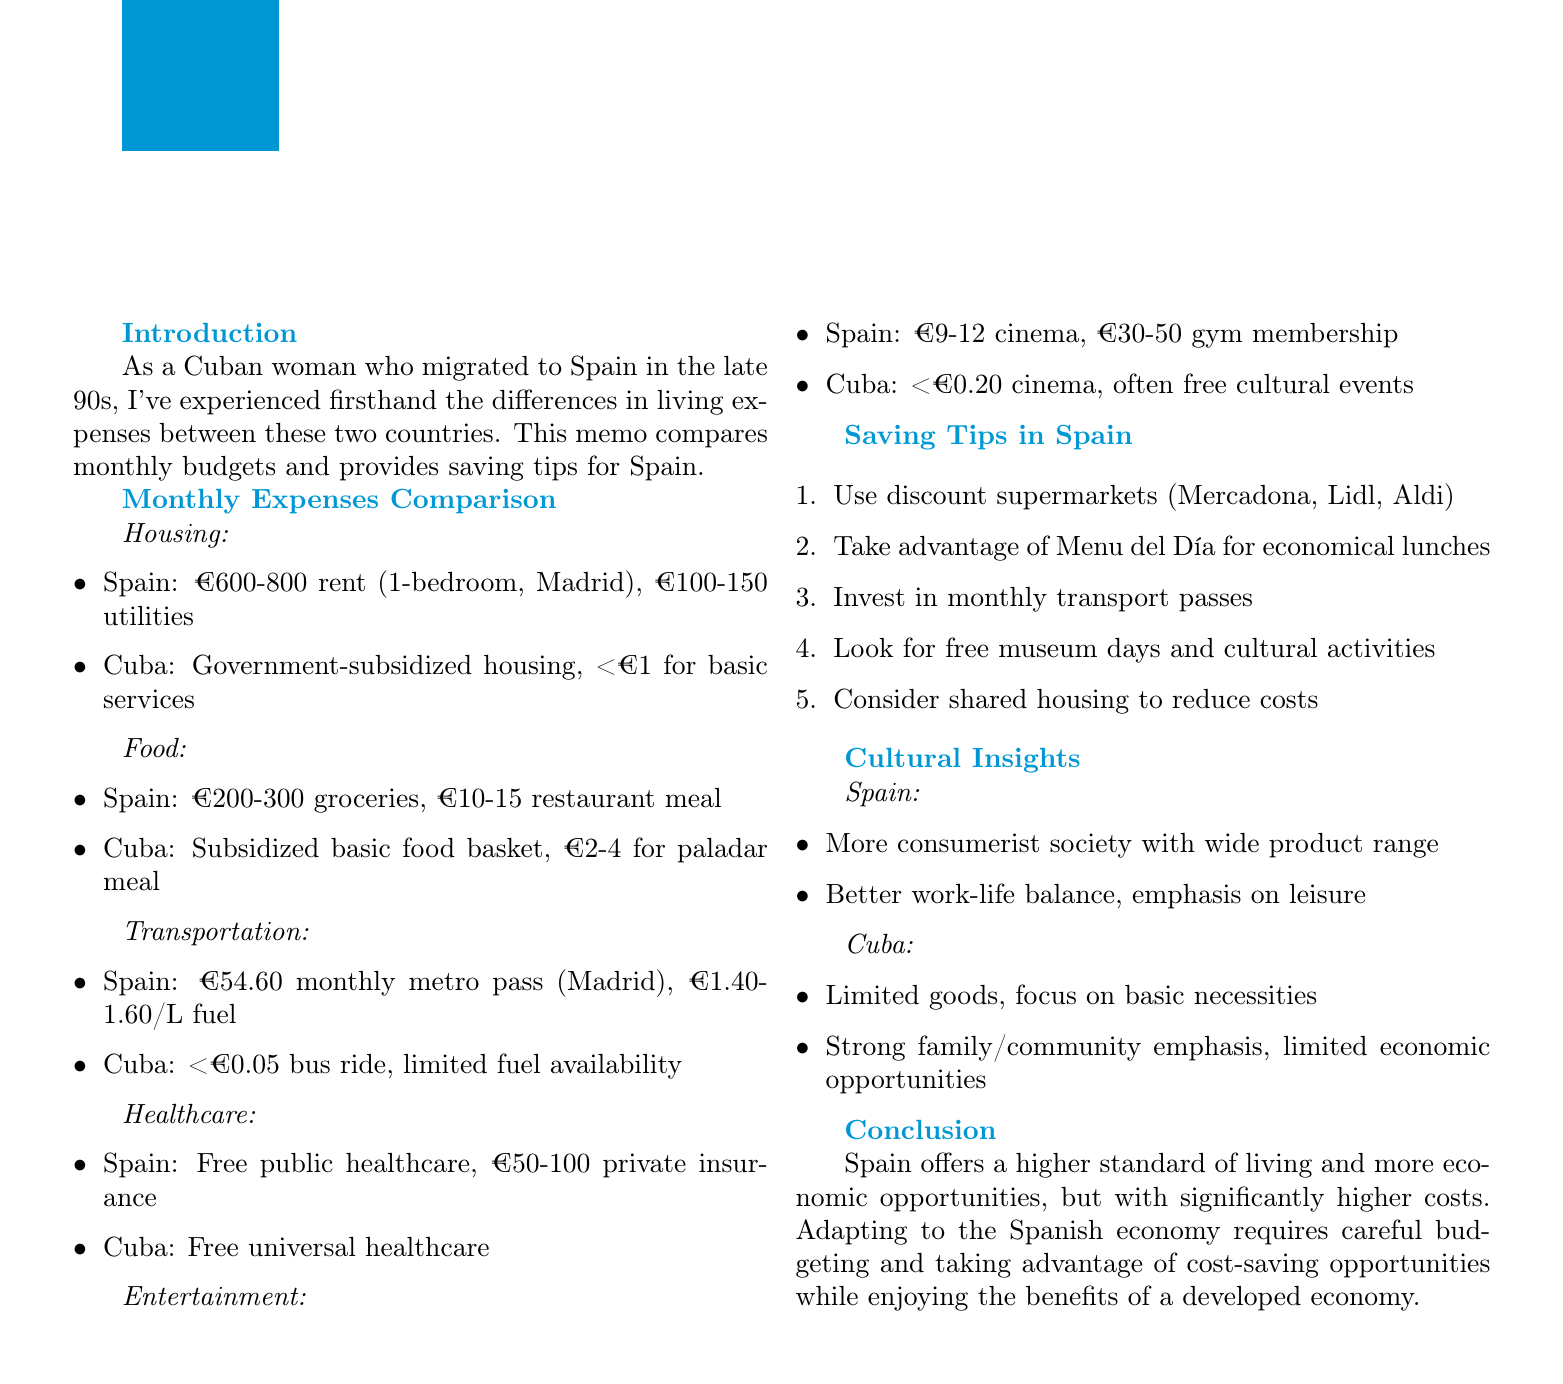What is the rent range for a 1-bedroom apartment in Madrid? The document specifies the rent range for a 1-bedroom apartment in Madrid as €600-800.
Answer: €600-800 How much is the monthly metro pass in Madrid? The memo states that the monthly metro pass in Madrid costs €54.60.
Answer: €54.60 What is the cost of utilities in Cuba? According to the document, utilities in Cuba cost 10-20 CUP (less than €1).
Answer: 10-20 CUP (less than €1) What is one tip for saving money on groceries in Spain? The memo suggests using discount supermarkets like Mercadona, Lidl, or Aldi for better prices.
Answer: Use discount supermarkets Which has a higher cost of eating out, Spain or Cuba? The comparison shows that eating out in Spain is more expensive than in Cuba.
Answer: Spain What type of healthcare is available for free in both countries? The document notes that public healthcare is free in both Spain and Cuba.
Answer: Public healthcare What is the typical price for a cinema ticket in Spain? The memo indicates that the cinema ticket price in Spain ranges from €9-12.
Answer: €9-12 What cultural insight does the document provide about Spain? It describes Spain as a more consumerist society with a wide range of products and services.
Answer: More consumerist society What is a benefit of shared housing mentioned in the memo? The document suggests that renting a room in a shared apartment can significantly reduce housing costs.
Answer: Significantly reduce housing costs 